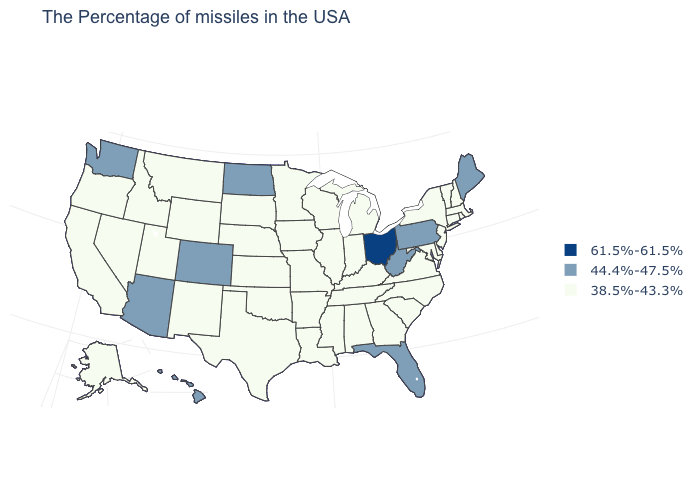Does New Mexico have a lower value than Vermont?
Give a very brief answer. No. What is the value of New Hampshire?
Write a very short answer. 38.5%-43.3%. Name the states that have a value in the range 38.5%-43.3%?
Be succinct. Massachusetts, Rhode Island, New Hampshire, Vermont, Connecticut, New York, New Jersey, Delaware, Maryland, Virginia, North Carolina, South Carolina, Georgia, Michigan, Kentucky, Indiana, Alabama, Tennessee, Wisconsin, Illinois, Mississippi, Louisiana, Missouri, Arkansas, Minnesota, Iowa, Kansas, Nebraska, Oklahoma, Texas, South Dakota, Wyoming, New Mexico, Utah, Montana, Idaho, Nevada, California, Oregon, Alaska. Does Wyoming have the lowest value in the USA?
Concise answer only. Yes. What is the value of Maryland?
Concise answer only. 38.5%-43.3%. Which states have the highest value in the USA?
Concise answer only. Ohio. Does the first symbol in the legend represent the smallest category?
Answer briefly. No. Which states have the lowest value in the MidWest?
Concise answer only. Michigan, Indiana, Wisconsin, Illinois, Missouri, Minnesota, Iowa, Kansas, Nebraska, South Dakota. Name the states that have a value in the range 61.5%-61.5%?
Short answer required. Ohio. What is the value of New York?
Give a very brief answer. 38.5%-43.3%. What is the value of South Dakota?
Short answer required. 38.5%-43.3%. What is the lowest value in the MidWest?
Answer briefly. 38.5%-43.3%. How many symbols are there in the legend?
Give a very brief answer. 3. Among the states that border Kansas , which have the highest value?
Write a very short answer. Colorado. How many symbols are there in the legend?
Give a very brief answer. 3. 